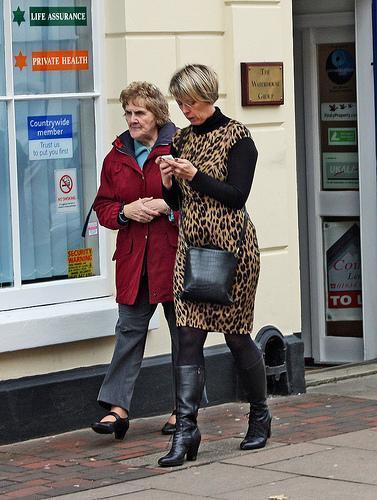How many women are walking?
Give a very brief answer. 2. How many people are pressing phone?
Give a very brief answer. 1. 